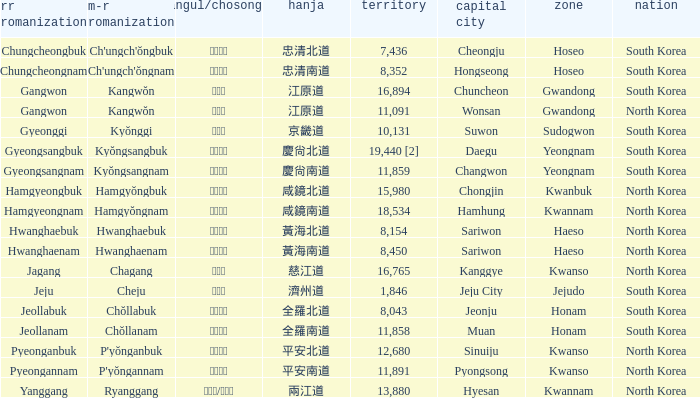Which country has a city with a Hanja of 平安北道? North Korea. 